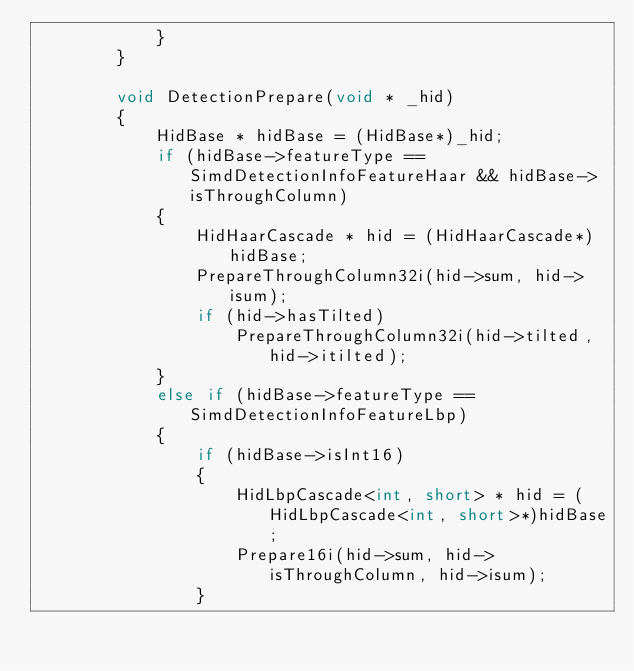Convert code to text. <code><loc_0><loc_0><loc_500><loc_500><_C++_>            }
        }

        void DetectionPrepare(void * _hid)
        {
            HidBase * hidBase = (HidBase*)_hid;
            if (hidBase->featureType == SimdDetectionInfoFeatureHaar && hidBase->isThroughColumn)
            {
                HidHaarCascade * hid = (HidHaarCascade*)hidBase;
                PrepareThroughColumn32i(hid->sum, hid->isum);
                if (hid->hasTilted)
                    PrepareThroughColumn32i(hid->tilted, hid->itilted);
            }
            else if (hidBase->featureType == SimdDetectionInfoFeatureLbp)
            {
                if (hidBase->isInt16)
                {
                    HidLbpCascade<int, short> * hid = (HidLbpCascade<int, short>*)hidBase;
                    Prepare16i(hid->sum, hid->isThroughColumn, hid->isum);
                }</code> 